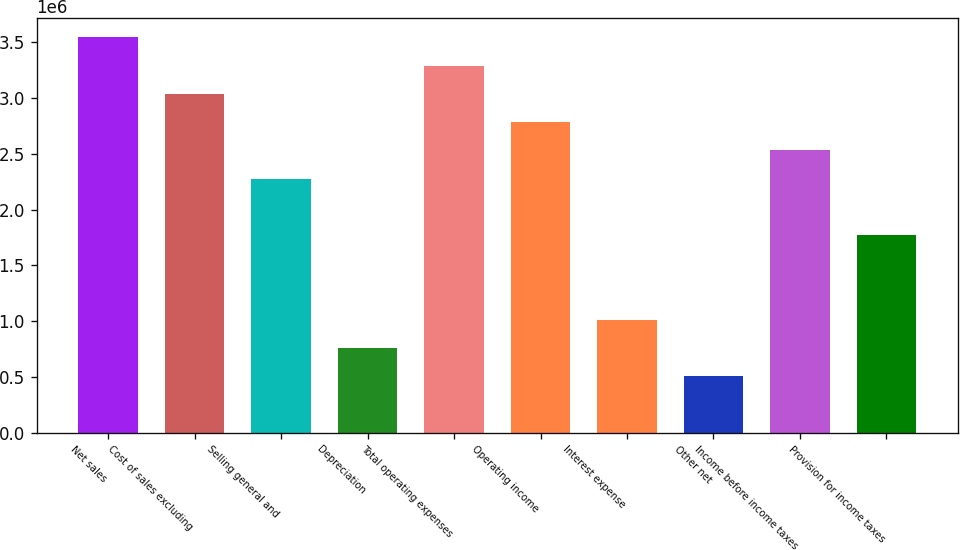Convert chart. <chart><loc_0><loc_0><loc_500><loc_500><bar_chart><fcel>Net sales<fcel>Cost of sales excluding<fcel>Selling general and<fcel>Depreciation<fcel>Total operating expenses<fcel>Operating income<fcel>Interest expense<fcel>Other net<fcel>Income before income taxes<fcel>Provision for income taxes<nl><fcel>3.54359e+06<fcel>3.03736e+06<fcel>2.27802e+06<fcel>759342<fcel>3.29047e+06<fcel>2.78425e+06<fcel>1.01246e+06<fcel>506229<fcel>2.53114e+06<fcel>1.7718e+06<nl></chart> 